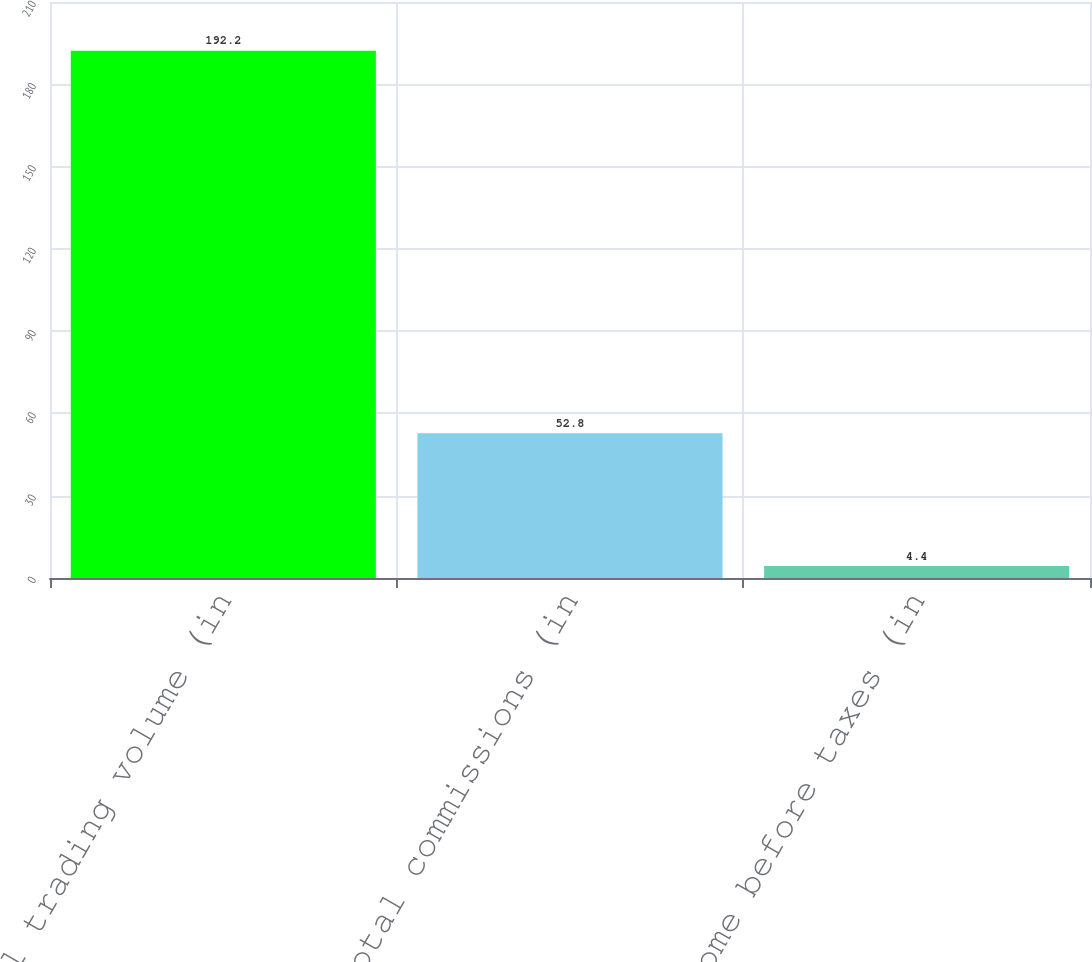<chart> <loc_0><loc_0><loc_500><loc_500><bar_chart><fcel>Total trading volume (in<fcel>Total commissions (in<fcel>Income before taxes (in<nl><fcel>192.2<fcel>52.8<fcel>4.4<nl></chart> 